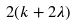<formula> <loc_0><loc_0><loc_500><loc_500>2 ( k + 2 \lambda )</formula> 